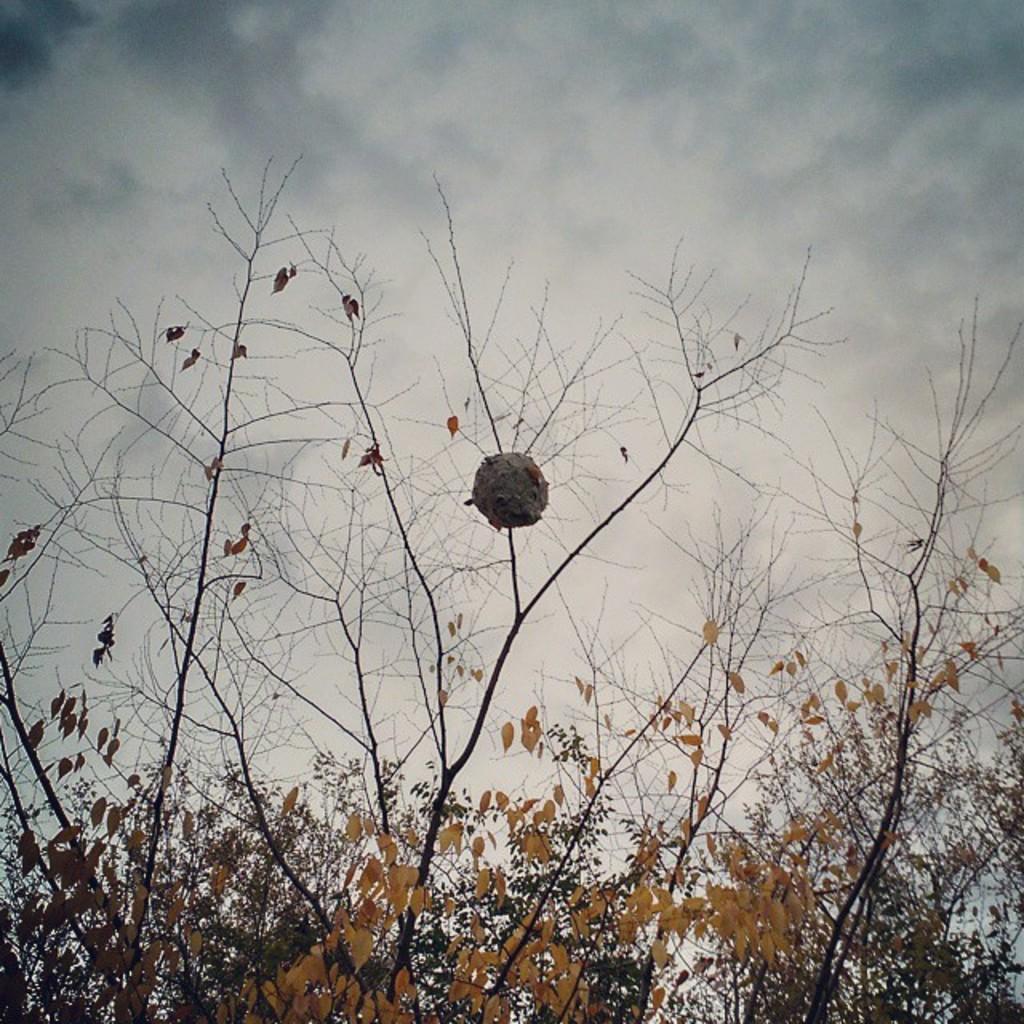Describe this image in one or two sentences. In this picture there are trees. At the top there is sky and there are clouds. 